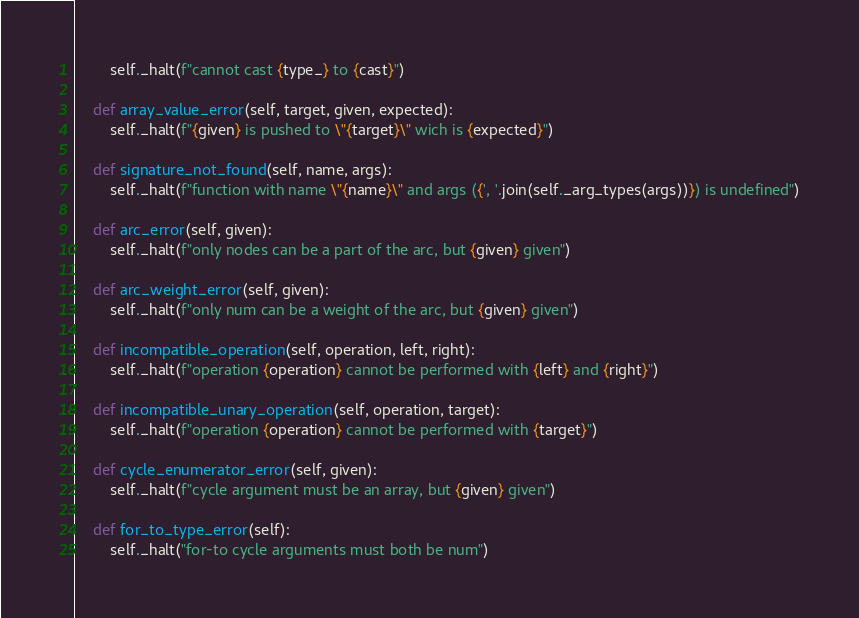Convert code to text. <code><loc_0><loc_0><loc_500><loc_500><_Python_>        self._halt(f"cannot cast {type_} to {cast}")

    def array_value_error(self, target, given, expected):
        self._halt(f"{given} is pushed to \"{target}\" wich is {expected}")

    def signature_not_found(self, name, args):
        self._halt(f"function with name \"{name}\" and args ({', '.join(self._arg_types(args))}) is undefined")

    def arc_error(self, given):
        self._halt(f"only nodes can be a part of the arc, but {given} given")

    def arc_weight_error(self, given):
        self._halt(f"only num can be a weight of the arc, but {given} given")

    def incompatible_operation(self, operation, left, right):
        self._halt(f"operation {operation} cannot be performed with {left} and {right}")

    def incompatible_unary_operation(self, operation, target):
        self._halt(f"operation {operation} cannot be performed with {target}")

    def cycle_enumerator_error(self, given):
        self._halt(f"cycle argument must be an array, but {given} given")

    def for_to_type_error(self):
        self._halt("for-to cycle arguments must both be num")
</code> 